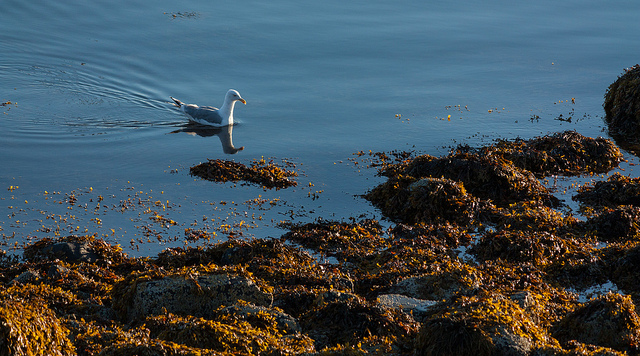Can you describe the environment in which the bird is found? The bird is found in a serene marine coastal setting, likely a harbor or cove. The water is calm, suggesting that it is somewhat sheltered, and there are patches of seaweed strewn over the rocks near the shore, indicating tidal activity. This habitat is typical for various seabirds, including the gull pictured. 